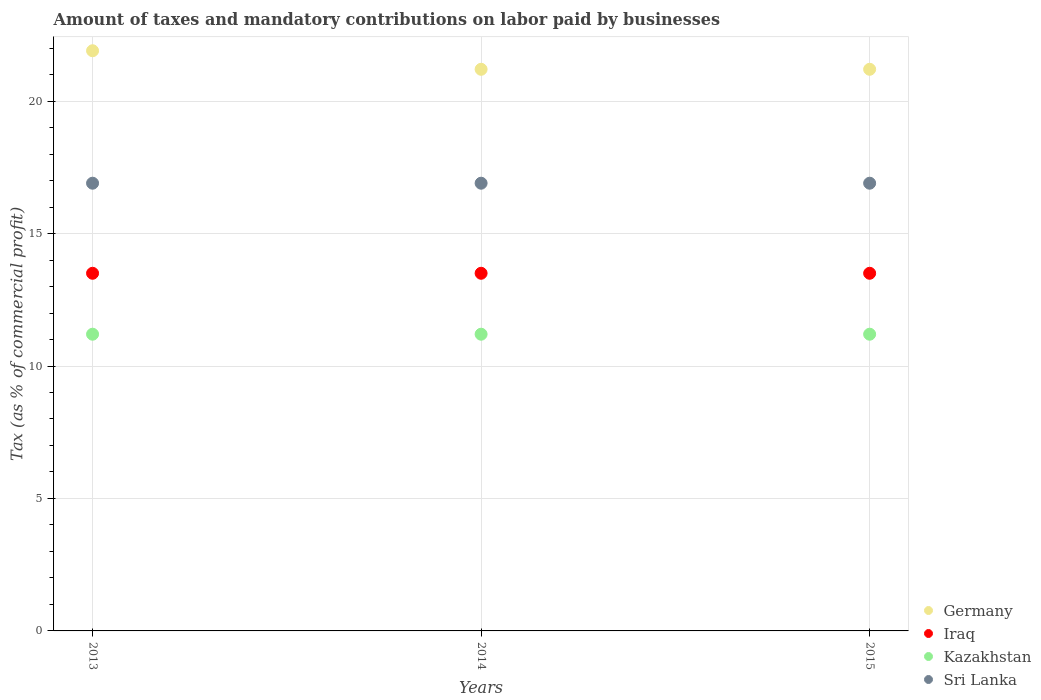Is the number of dotlines equal to the number of legend labels?
Make the answer very short. Yes. What is the percentage of taxes paid by businesses in Kazakhstan in 2014?
Provide a short and direct response. 11.2. Across all years, what is the maximum percentage of taxes paid by businesses in Kazakhstan?
Offer a terse response. 11.2. Across all years, what is the minimum percentage of taxes paid by businesses in Germany?
Provide a succinct answer. 21.2. In which year was the percentage of taxes paid by businesses in Germany maximum?
Make the answer very short. 2013. In which year was the percentage of taxes paid by businesses in Germany minimum?
Provide a succinct answer. 2014. What is the total percentage of taxes paid by businesses in Sri Lanka in the graph?
Your answer should be very brief. 50.7. What is the difference between the percentage of taxes paid by businesses in Germany in 2015 and the percentage of taxes paid by businesses in Sri Lanka in 2014?
Keep it short and to the point. 4.3. What is the average percentage of taxes paid by businesses in Germany per year?
Give a very brief answer. 21.43. In the year 2015, what is the difference between the percentage of taxes paid by businesses in Germany and percentage of taxes paid by businesses in Sri Lanka?
Provide a succinct answer. 4.3. What is the ratio of the percentage of taxes paid by businesses in Kazakhstan in 2013 to that in 2015?
Offer a terse response. 1. What is the difference between the highest and the second highest percentage of taxes paid by businesses in Germany?
Ensure brevity in your answer.  0.7. Is the sum of the percentage of taxes paid by businesses in Iraq in 2013 and 2015 greater than the maximum percentage of taxes paid by businesses in Sri Lanka across all years?
Your answer should be compact. Yes. Is it the case that in every year, the sum of the percentage of taxes paid by businesses in Kazakhstan and percentage of taxes paid by businesses in Iraq  is greater than the percentage of taxes paid by businesses in Sri Lanka?
Ensure brevity in your answer.  Yes. Does the percentage of taxes paid by businesses in Kazakhstan monotonically increase over the years?
Ensure brevity in your answer.  No. How many years are there in the graph?
Provide a short and direct response. 3. Are the values on the major ticks of Y-axis written in scientific E-notation?
Offer a terse response. No. Does the graph contain any zero values?
Provide a succinct answer. No. Does the graph contain grids?
Ensure brevity in your answer.  Yes. How many legend labels are there?
Offer a very short reply. 4. How are the legend labels stacked?
Ensure brevity in your answer.  Vertical. What is the title of the graph?
Your response must be concise. Amount of taxes and mandatory contributions on labor paid by businesses. Does "Fragile and conflict affected situations" appear as one of the legend labels in the graph?
Your answer should be very brief. No. What is the label or title of the Y-axis?
Provide a short and direct response. Tax (as % of commercial profit). What is the Tax (as % of commercial profit) of Germany in 2013?
Offer a terse response. 21.9. What is the Tax (as % of commercial profit) in Iraq in 2013?
Make the answer very short. 13.5. What is the Tax (as % of commercial profit) in Kazakhstan in 2013?
Provide a succinct answer. 11.2. What is the Tax (as % of commercial profit) of Germany in 2014?
Provide a succinct answer. 21.2. What is the Tax (as % of commercial profit) of Kazakhstan in 2014?
Offer a terse response. 11.2. What is the Tax (as % of commercial profit) in Germany in 2015?
Offer a very short reply. 21.2. What is the Tax (as % of commercial profit) of Kazakhstan in 2015?
Make the answer very short. 11.2. What is the Tax (as % of commercial profit) in Sri Lanka in 2015?
Offer a very short reply. 16.9. Across all years, what is the maximum Tax (as % of commercial profit) of Germany?
Offer a very short reply. 21.9. Across all years, what is the maximum Tax (as % of commercial profit) of Kazakhstan?
Provide a short and direct response. 11.2. Across all years, what is the minimum Tax (as % of commercial profit) in Germany?
Provide a short and direct response. 21.2. What is the total Tax (as % of commercial profit) in Germany in the graph?
Your response must be concise. 64.3. What is the total Tax (as % of commercial profit) of Iraq in the graph?
Keep it short and to the point. 40.5. What is the total Tax (as % of commercial profit) of Kazakhstan in the graph?
Provide a succinct answer. 33.6. What is the total Tax (as % of commercial profit) of Sri Lanka in the graph?
Provide a short and direct response. 50.7. What is the difference between the Tax (as % of commercial profit) of Germany in 2013 and that in 2014?
Provide a short and direct response. 0.7. What is the difference between the Tax (as % of commercial profit) of Iraq in 2013 and that in 2014?
Give a very brief answer. 0. What is the difference between the Tax (as % of commercial profit) of Sri Lanka in 2013 and that in 2014?
Ensure brevity in your answer.  0. What is the difference between the Tax (as % of commercial profit) of Kazakhstan in 2013 and that in 2015?
Ensure brevity in your answer.  0. What is the difference between the Tax (as % of commercial profit) in Germany in 2014 and that in 2015?
Ensure brevity in your answer.  0. What is the difference between the Tax (as % of commercial profit) in Kazakhstan in 2014 and that in 2015?
Offer a very short reply. 0. What is the difference between the Tax (as % of commercial profit) of Germany in 2013 and the Tax (as % of commercial profit) of Sri Lanka in 2014?
Offer a terse response. 5. What is the difference between the Tax (as % of commercial profit) of Germany in 2013 and the Tax (as % of commercial profit) of Iraq in 2015?
Provide a short and direct response. 8.4. What is the difference between the Tax (as % of commercial profit) in Iraq in 2013 and the Tax (as % of commercial profit) in Kazakhstan in 2015?
Ensure brevity in your answer.  2.3. What is the difference between the Tax (as % of commercial profit) of Iraq in 2013 and the Tax (as % of commercial profit) of Sri Lanka in 2015?
Offer a terse response. -3.4. What is the difference between the Tax (as % of commercial profit) in Germany in 2014 and the Tax (as % of commercial profit) in Iraq in 2015?
Your answer should be compact. 7.7. What is the difference between the Tax (as % of commercial profit) in Germany in 2014 and the Tax (as % of commercial profit) in Kazakhstan in 2015?
Provide a succinct answer. 10. What is the difference between the Tax (as % of commercial profit) of Germany in 2014 and the Tax (as % of commercial profit) of Sri Lanka in 2015?
Make the answer very short. 4.3. What is the difference between the Tax (as % of commercial profit) in Iraq in 2014 and the Tax (as % of commercial profit) in Sri Lanka in 2015?
Your answer should be compact. -3.4. What is the difference between the Tax (as % of commercial profit) of Kazakhstan in 2014 and the Tax (as % of commercial profit) of Sri Lanka in 2015?
Your response must be concise. -5.7. What is the average Tax (as % of commercial profit) of Germany per year?
Give a very brief answer. 21.43. What is the average Tax (as % of commercial profit) in Iraq per year?
Provide a succinct answer. 13.5. What is the average Tax (as % of commercial profit) of Kazakhstan per year?
Offer a terse response. 11.2. In the year 2013, what is the difference between the Tax (as % of commercial profit) of Germany and Tax (as % of commercial profit) of Kazakhstan?
Your answer should be very brief. 10.7. In the year 2014, what is the difference between the Tax (as % of commercial profit) of Germany and Tax (as % of commercial profit) of Iraq?
Your answer should be very brief. 7.7. In the year 2014, what is the difference between the Tax (as % of commercial profit) in Germany and Tax (as % of commercial profit) in Sri Lanka?
Give a very brief answer. 4.3. In the year 2014, what is the difference between the Tax (as % of commercial profit) in Iraq and Tax (as % of commercial profit) in Kazakhstan?
Ensure brevity in your answer.  2.3. In the year 2015, what is the difference between the Tax (as % of commercial profit) in Germany and Tax (as % of commercial profit) in Kazakhstan?
Ensure brevity in your answer.  10. What is the ratio of the Tax (as % of commercial profit) of Germany in 2013 to that in 2014?
Your answer should be very brief. 1.03. What is the ratio of the Tax (as % of commercial profit) in Kazakhstan in 2013 to that in 2014?
Ensure brevity in your answer.  1. What is the ratio of the Tax (as % of commercial profit) in Germany in 2013 to that in 2015?
Ensure brevity in your answer.  1.03. What is the ratio of the Tax (as % of commercial profit) of Iraq in 2013 to that in 2015?
Your answer should be compact. 1. What is the ratio of the Tax (as % of commercial profit) in Kazakhstan in 2013 to that in 2015?
Provide a succinct answer. 1. What is the ratio of the Tax (as % of commercial profit) of Germany in 2014 to that in 2015?
Offer a terse response. 1. What is the ratio of the Tax (as % of commercial profit) of Kazakhstan in 2014 to that in 2015?
Offer a terse response. 1. What is the ratio of the Tax (as % of commercial profit) in Sri Lanka in 2014 to that in 2015?
Your answer should be very brief. 1. What is the difference between the highest and the second highest Tax (as % of commercial profit) of Kazakhstan?
Your answer should be very brief. 0. What is the difference between the highest and the second highest Tax (as % of commercial profit) of Sri Lanka?
Provide a short and direct response. 0. What is the difference between the highest and the lowest Tax (as % of commercial profit) of Iraq?
Make the answer very short. 0. What is the difference between the highest and the lowest Tax (as % of commercial profit) in Kazakhstan?
Your answer should be compact. 0. 